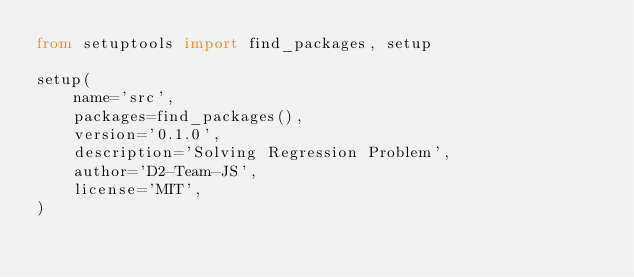Convert code to text. <code><loc_0><loc_0><loc_500><loc_500><_Python_>from setuptools import find_packages, setup

setup(
    name='src',
    packages=find_packages(),
    version='0.1.0',
    description='Solving Regression Problem',
    author='D2-Team-JS',
    license='MIT',
)
</code> 